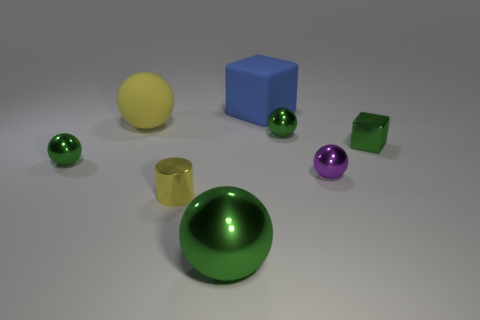Is the material of the tiny green ball on the right side of the yellow cylinder the same as the large blue block?
Offer a very short reply. No. What material is the small green object that is the same shape as the big blue thing?
Make the answer very short. Metal. What is the material of the block that is the same color as the big shiny object?
Ensure brevity in your answer.  Metal. Is the number of big matte blocks less than the number of cubes?
Your response must be concise. Yes. There is a large matte thing on the left side of the big block; does it have the same color as the rubber block?
Your answer should be very brief. No. What is the color of the sphere that is the same material as the large blue cube?
Keep it short and to the point. Yellow. Is the size of the yellow matte thing the same as the purple metal sphere?
Keep it short and to the point. No. What is the blue cube made of?
Your response must be concise. Rubber. There is a purple thing that is the same size as the yellow cylinder; what is it made of?
Offer a terse response. Metal. Are there any purple metal spheres of the same size as the blue rubber block?
Your answer should be compact. No. 